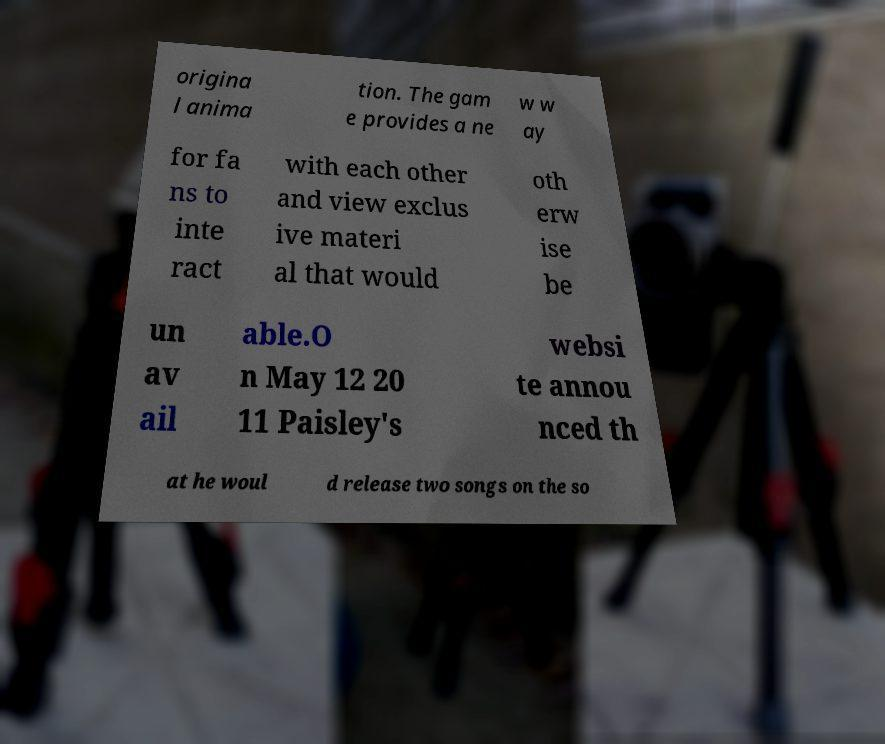Can you read and provide the text displayed in the image?This photo seems to have some interesting text. Can you extract and type it out for me? origina l anima tion. The gam e provides a ne w w ay for fa ns to inte ract with each other and view exclus ive materi al that would oth erw ise be un av ail able.O n May 12 20 11 Paisley's websi te annou nced th at he woul d release two songs on the so 